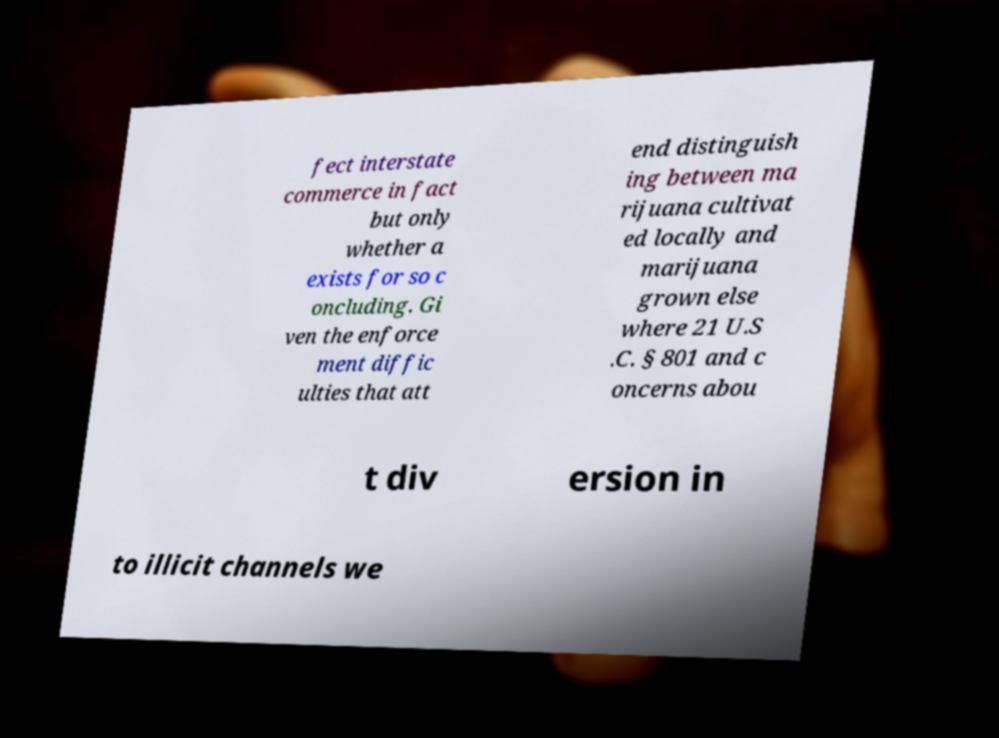For documentation purposes, I need the text within this image transcribed. Could you provide that? fect interstate commerce in fact but only whether a exists for so c oncluding. Gi ven the enforce ment diffic ulties that att end distinguish ing between ma rijuana cultivat ed locally and marijuana grown else where 21 U.S .C. § 801 and c oncerns abou t div ersion in to illicit channels we 